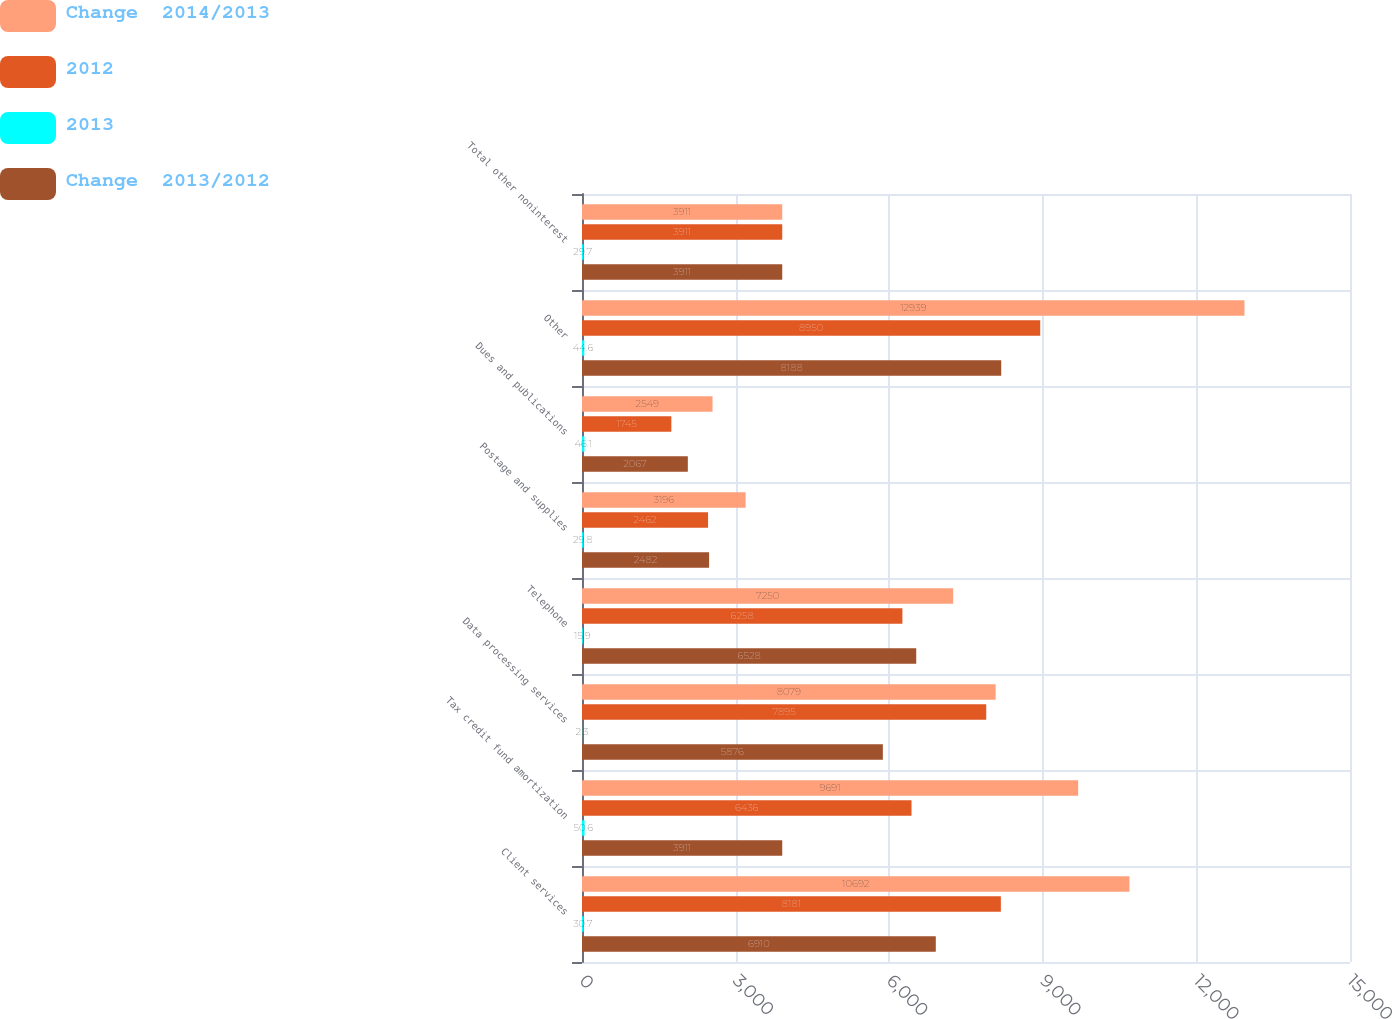Convert chart to OTSL. <chart><loc_0><loc_0><loc_500><loc_500><stacked_bar_chart><ecel><fcel>Client services<fcel>Tax credit fund amortization<fcel>Data processing services<fcel>Telephone<fcel>Postage and supplies<fcel>Dues and publications<fcel>Other<fcel>Total other noninterest<nl><fcel>Change  2014/2013<fcel>10692<fcel>9691<fcel>8079<fcel>7250<fcel>3196<fcel>2549<fcel>12939<fcel>3911<nl><fcel>2012<fcel>8181<fcel>6436<fcel>7895<fcel>6258<fcel>2462<fcel>1745<fcel>8950<fcel>3911<nl><fcel>2013<fcel>30.7<fcel>50.6<fcel>2.3<fcel>15.9<fcel>29.8<fcel>46.1<fcel>44.6<fcel>29.7<nl><fcel>Change  2013/2012<fcel>6910<fcel>3911<fcel>5876<fcel>6528<fcel>2482<fcel>2067<fcel>8188<fcel>3911<nl></chart> 